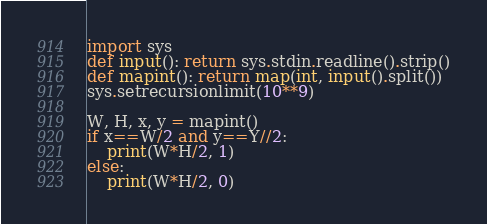Convert code to text. <code><loc_0><loc_0><loc_500><loc_500><_Python_>import sys
def input(): return sys.stdin.readline().strip()
def mapint(): return map(int, input().split())
sys.setrecursionlimit(10**9)

W, H, x, y = mapint()
if x==W/2 and y==Y//2:
    print(W*H/2, 1)
else:
    print(W*H/2, 0)</code> 